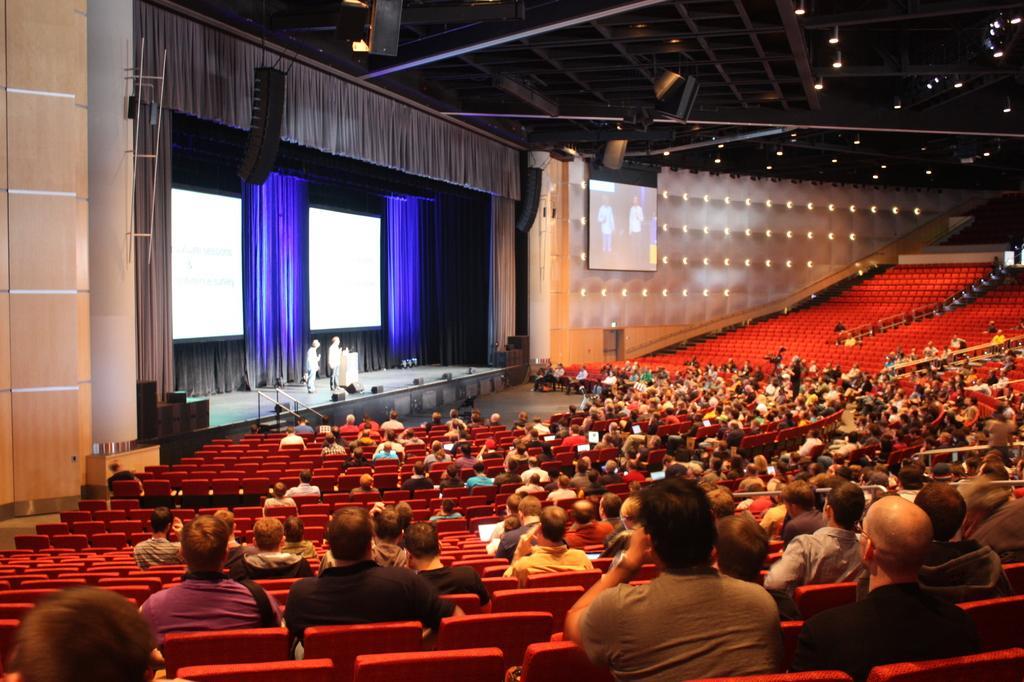Can you describe this image briefly? In the image I can see some people sitting on the chairs and also I can see some screens, lights and some other things around. 